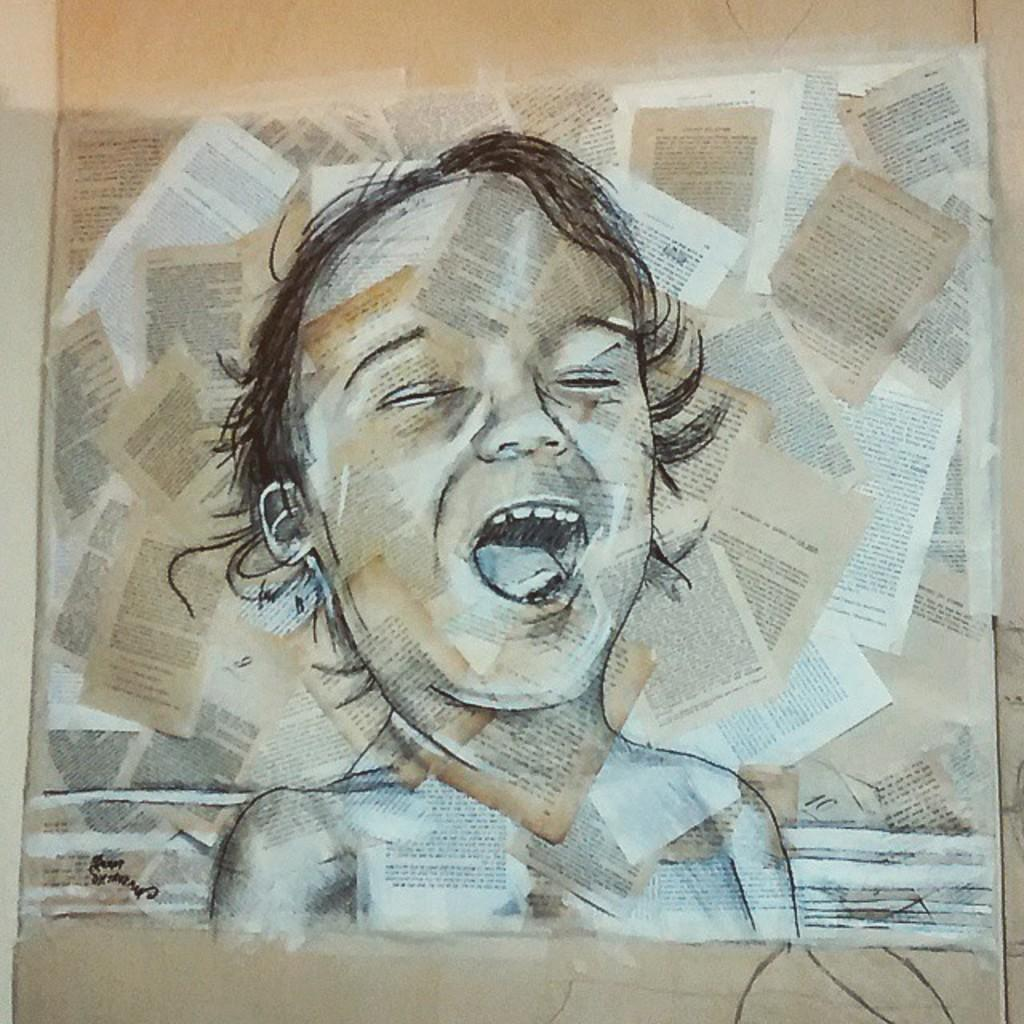What is the main subject of the painting in the image? The main subject of the painting in the image is a baby. What material is the painting on? The painting is on papers. What type of company is hosting an event in the hall depicted in the image? There is no hall or company present in the image; it features a painting of a baby on papers. 